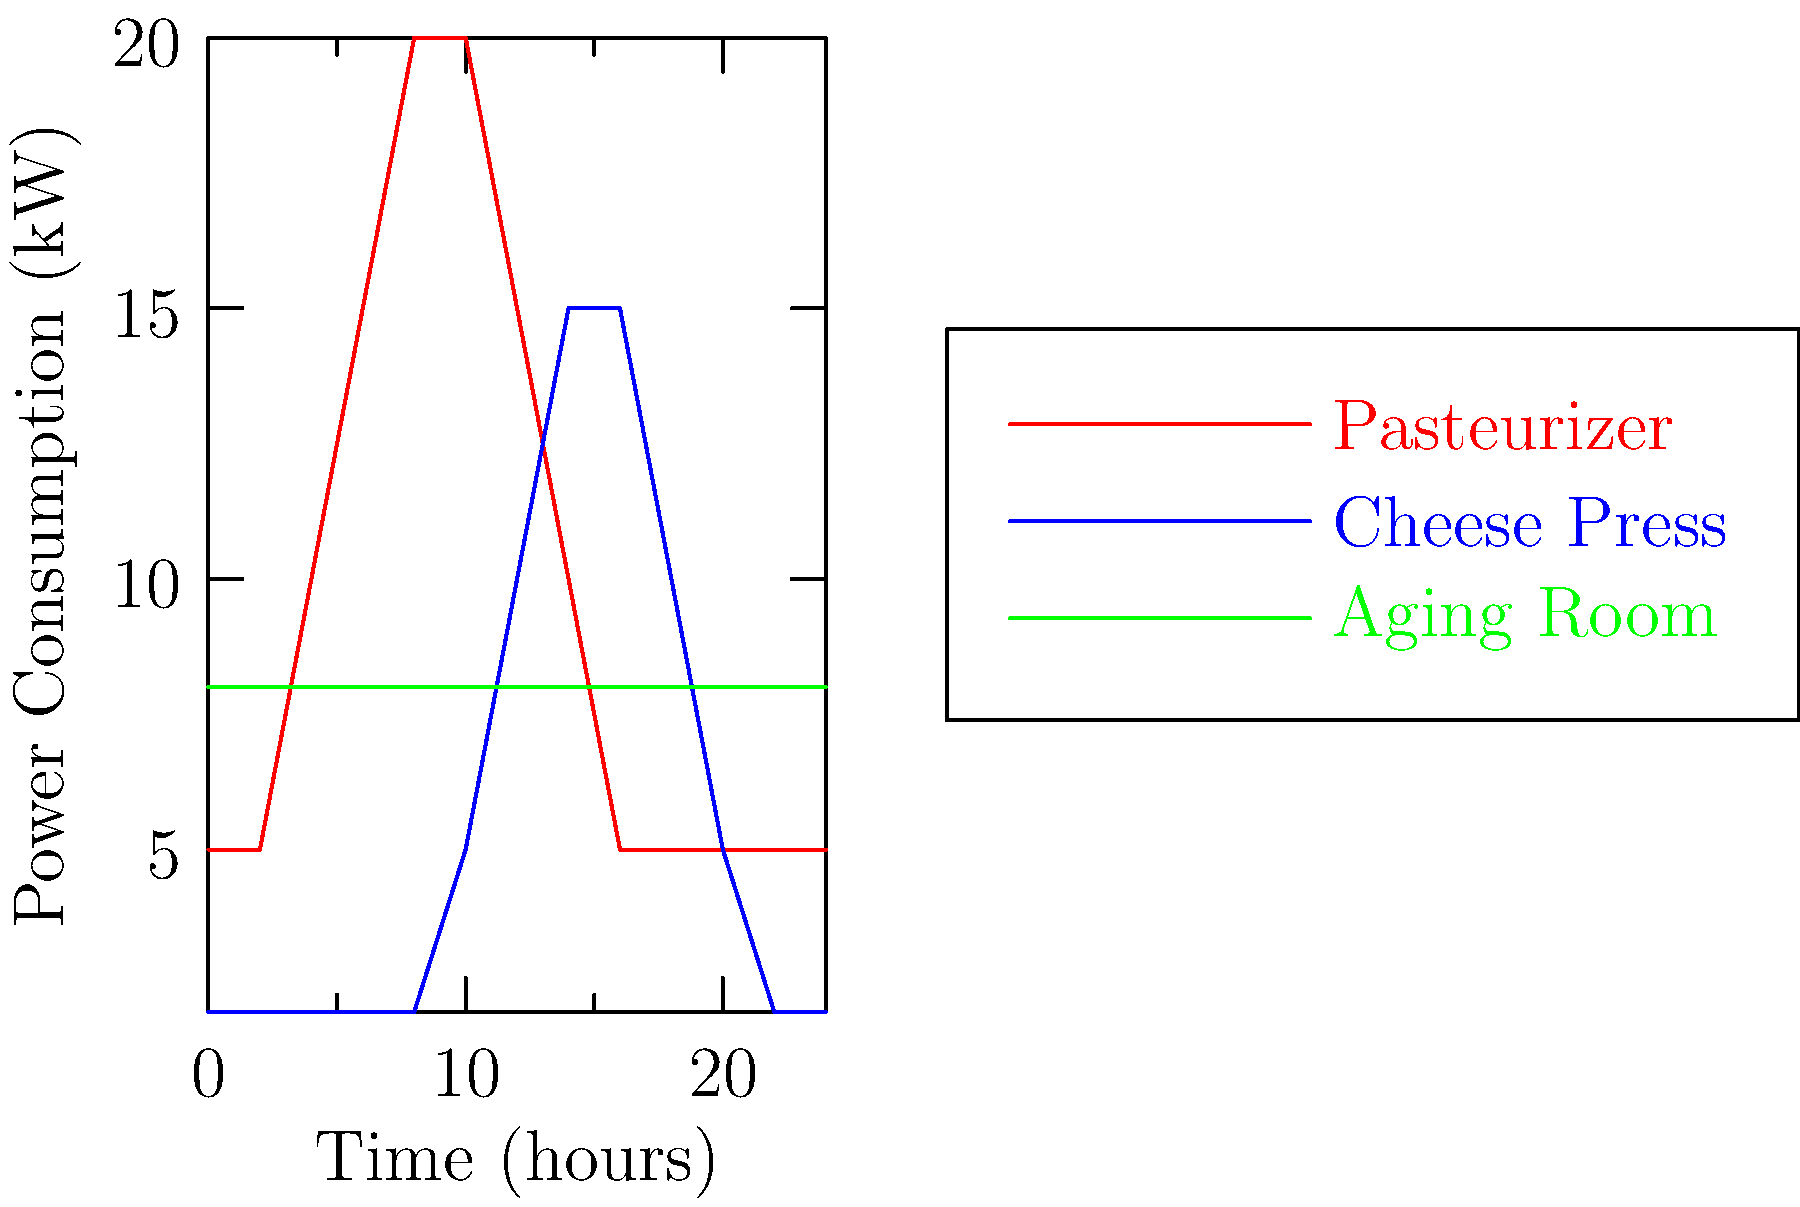Based on the graph showing power consumption patterns of different cheese-making equipment over a 24-hour period, which piece of equipment consumes the most energy during the early morning hours (around 2-4 AM)? To answer this question, we need to analyze the power consumption of each piece of equipment during the early morning hours (2-4 AM) on the graph:

1. Pasteurizer (red line):
   At 2-4 AM, the power consumption is about 5 kW.

2. Cheese Press (blue line):
   At 2-4 AM, the power consumption is about 2 kW.

3. Aging Room (green line):
   At 2-4 AM, the power consumption is constant at 8 kW.

Comparing these values, we can see that the Aging Room consumes the most energy during the early morning hours, with a constant power consumption of 8 kW. This is higher than both the Pasteurizer (5 kW) and the Cheese Press (2 kW) during the same time period.

The constant power consumption of the Aging Room is likely due to the need for consistent temperature and humidity control to ensure proper cheese aging, regardless of the time of day.
Answer: Aging Room 